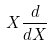Convert formula to latex. <formula><loc_0><loc_0><loc_500><loc_500>X \frac { d } { d X }</formula> 